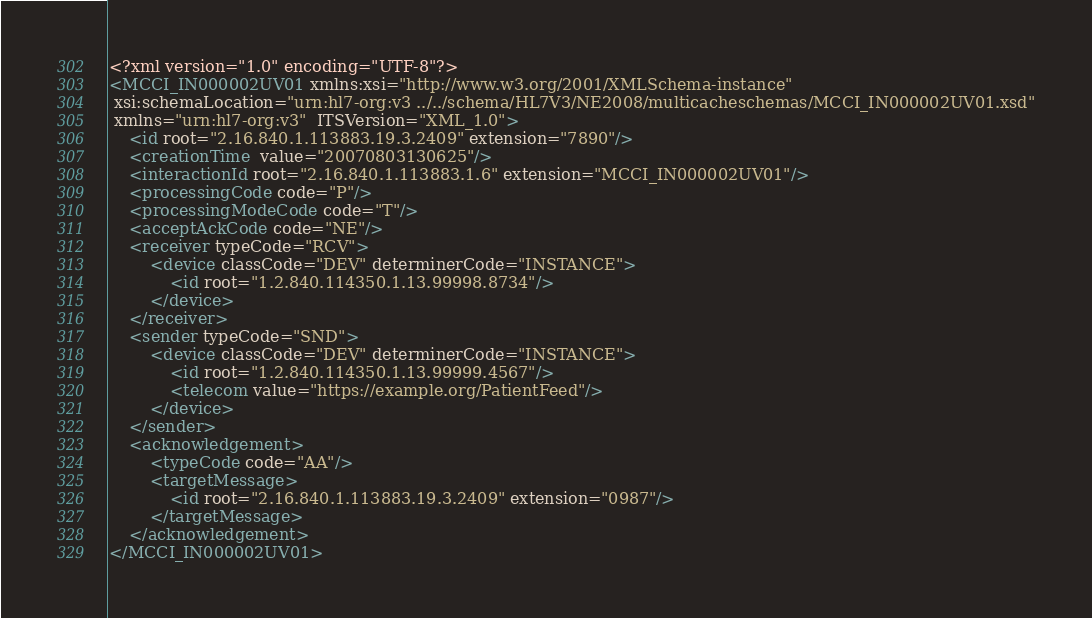Convert code to text. <code><loc_0><loc_0><loc_500><loc_500><_XML_><?xml version="1.0" encoding="UTF-8"?>
<MCCI_IN000002UV01 xmlns:xsi="http://www.w3.org/2001/XMLSchema-instance"
 xsi:schemaLocation="urn:hl7-org:v3 ../../schema/HL7V3/NE2008/multicacheschemas/MCCI_IN000002UV01.xsd"
 xmlns="urn:hl7-org:v3"  ITSVersion="XML_1.0">
    <id root="2.16.840.1.113883.19.3.2409" extension="7890"/>
    <creationTime  value="20070803130625"/>
    <interactionId root="2.16.840.1.113883.1.6" extension="MCCI_IN000002UV01"/>
    <processingCode code="P"/>
    <processingModeCode code="T"/>
    <acceptAckCode code="NE"/>
    <receiver typeCode="RCV">
        <device classCode="DEV" determinerCode="INSTANCE">
            <id root="1.2.840.114350.1.13.99998.8734"/>
        </device>
    </receiver>
    <sender typeCode="SND">
        <device classCode="DEV" determinerCode="INSTANCE">
            <id root="1.2.840.114350.1.13.99999.4567"/>
            <telecom value="https://example.org/PatientFeed"/>
        </device>
    </sender>
    <acknowledgement>
        <typeCode code="AA"/>
        <targetMessage>
            <id root="2.16.840.1.113883.19.3.2409" extension="0987"/>
        </targetMessage>
    </acknowledgement>
</MCCI_IN000002UV01>
</code> 